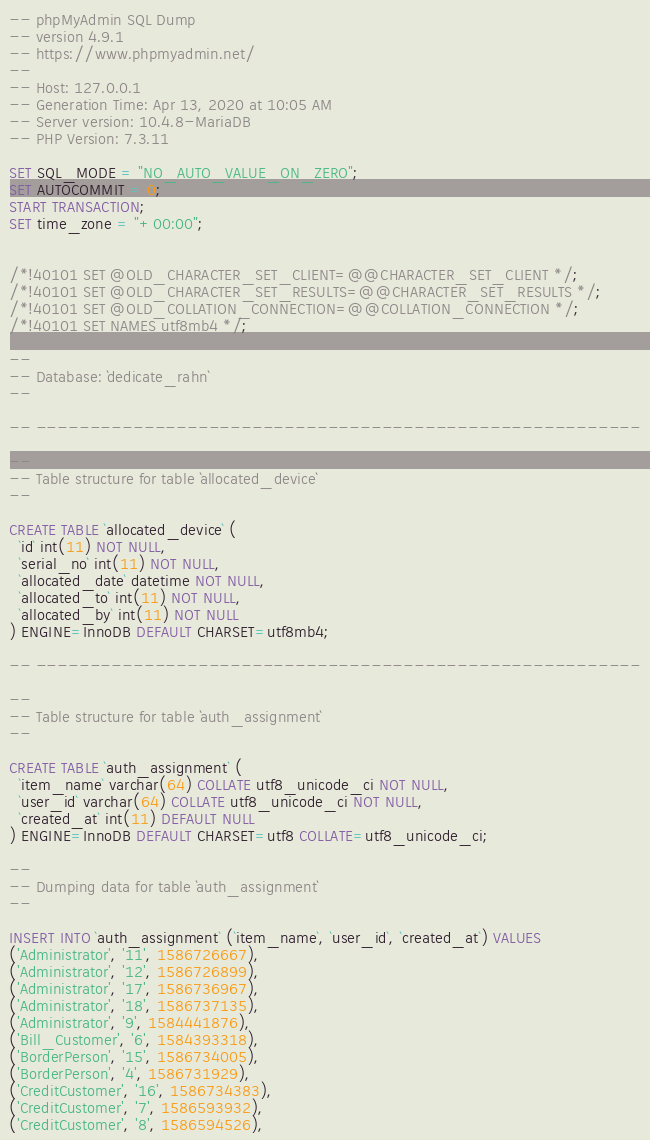<code> <loc_0><loc_0><loc_500><loc_500><_SQL_>-- phpMyAdmin SQL Dump
-- version 4.9.1
-- https://www.phpmyadmin.net/
--
-- Host: 127.0.0.1
-- Generation Time: Apr 13, 2020 at 10:05 AM
-- Server version: 10.4.8-MariaDB
-- PHP Version: 7.3.11

SET SQL_MODE = "NO_AUTO_VALUE_ON_ZERO";
SET AUTOCOMMIT = 0;
START TRANSACTION;
SET time_zone = "+00:00";


/*!40101 SET @OLD_CHARACTER_SET_CLIENT=@@CHARACTER_SET_CLIENT */;
/*!40101 SET @OLD_CHARACTER_SET_RESULTS=@@CHARACTER_SET_RESULTS */;
/*!40101 SET @OLD_COLLATION_CONNECTION=@@COLLATION_CONNECTION */;
/*!40101 SET NAMES utf8mb4 */;

--
-- Database: `dedicate_rahn`
--

-- --------------------------------------------------------

--
-- Table structure for table `allocated_device`
--

CREATE TABLE `allocated_device` (
  `id` int(11) NOT NULL,
  `serial_no` int(11) NOT NULL,
  `allocated_date` datetime NOT NULL,
  `allocated_to` int(11) NOT NULL,
  `allocated_by` int(11) NOT NULL
) ENGINE=InnoDB DEFAULT CHARSET=utf8mb4;

-- --------------------------------------------------------

--
-- Table structure for table `auth_assignment`
--

CREATE TABLE `auth_assignment` (
  `item_name` varchar(64) COLLATE utf8_unicode_ci NOT NULL,
  `user_id` varchar(64) COLLATE utf8_unicode_ci NOT NULL,
  `created_at` int(11) DEFAULT NULL
) ENGINE=InnoDB DEFAULT CHARSET=utf8 COLLATE=utf8_unicode_ci;

--
-- Dumping data for table `auth_assignment`
--

INSERT INTO `auth_assignment` (`item_name`, `user_id`, `created_at`) VALUES
('Administrator', '11', 1586726667),
('Administrator', '12', 1586726899),
('Administrator', '17', 1586736967),
('Administrator', '18', 1586737135),
('Administrator', '9', 1584441876),
('Bill_Customer', '6', 1584393318),
('BorderPerson', '15', 1586734005),
('BorderPerson', '4', 1586731929),
('CreditCustomer', '16', 1586734383),
('CreditCustomer', '7', 1586593932),
('CreditCustomer', '8', 1586594526),</code> 